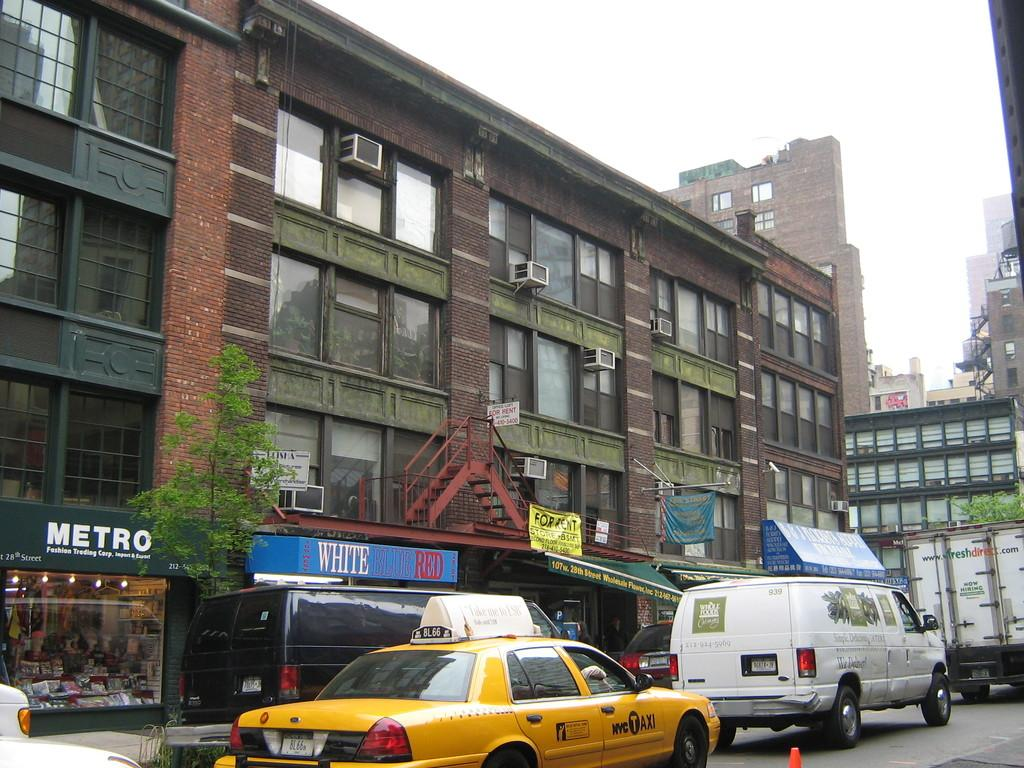<image>
Share a concise interpretation of the image provided. a metro sign that is next to the road 